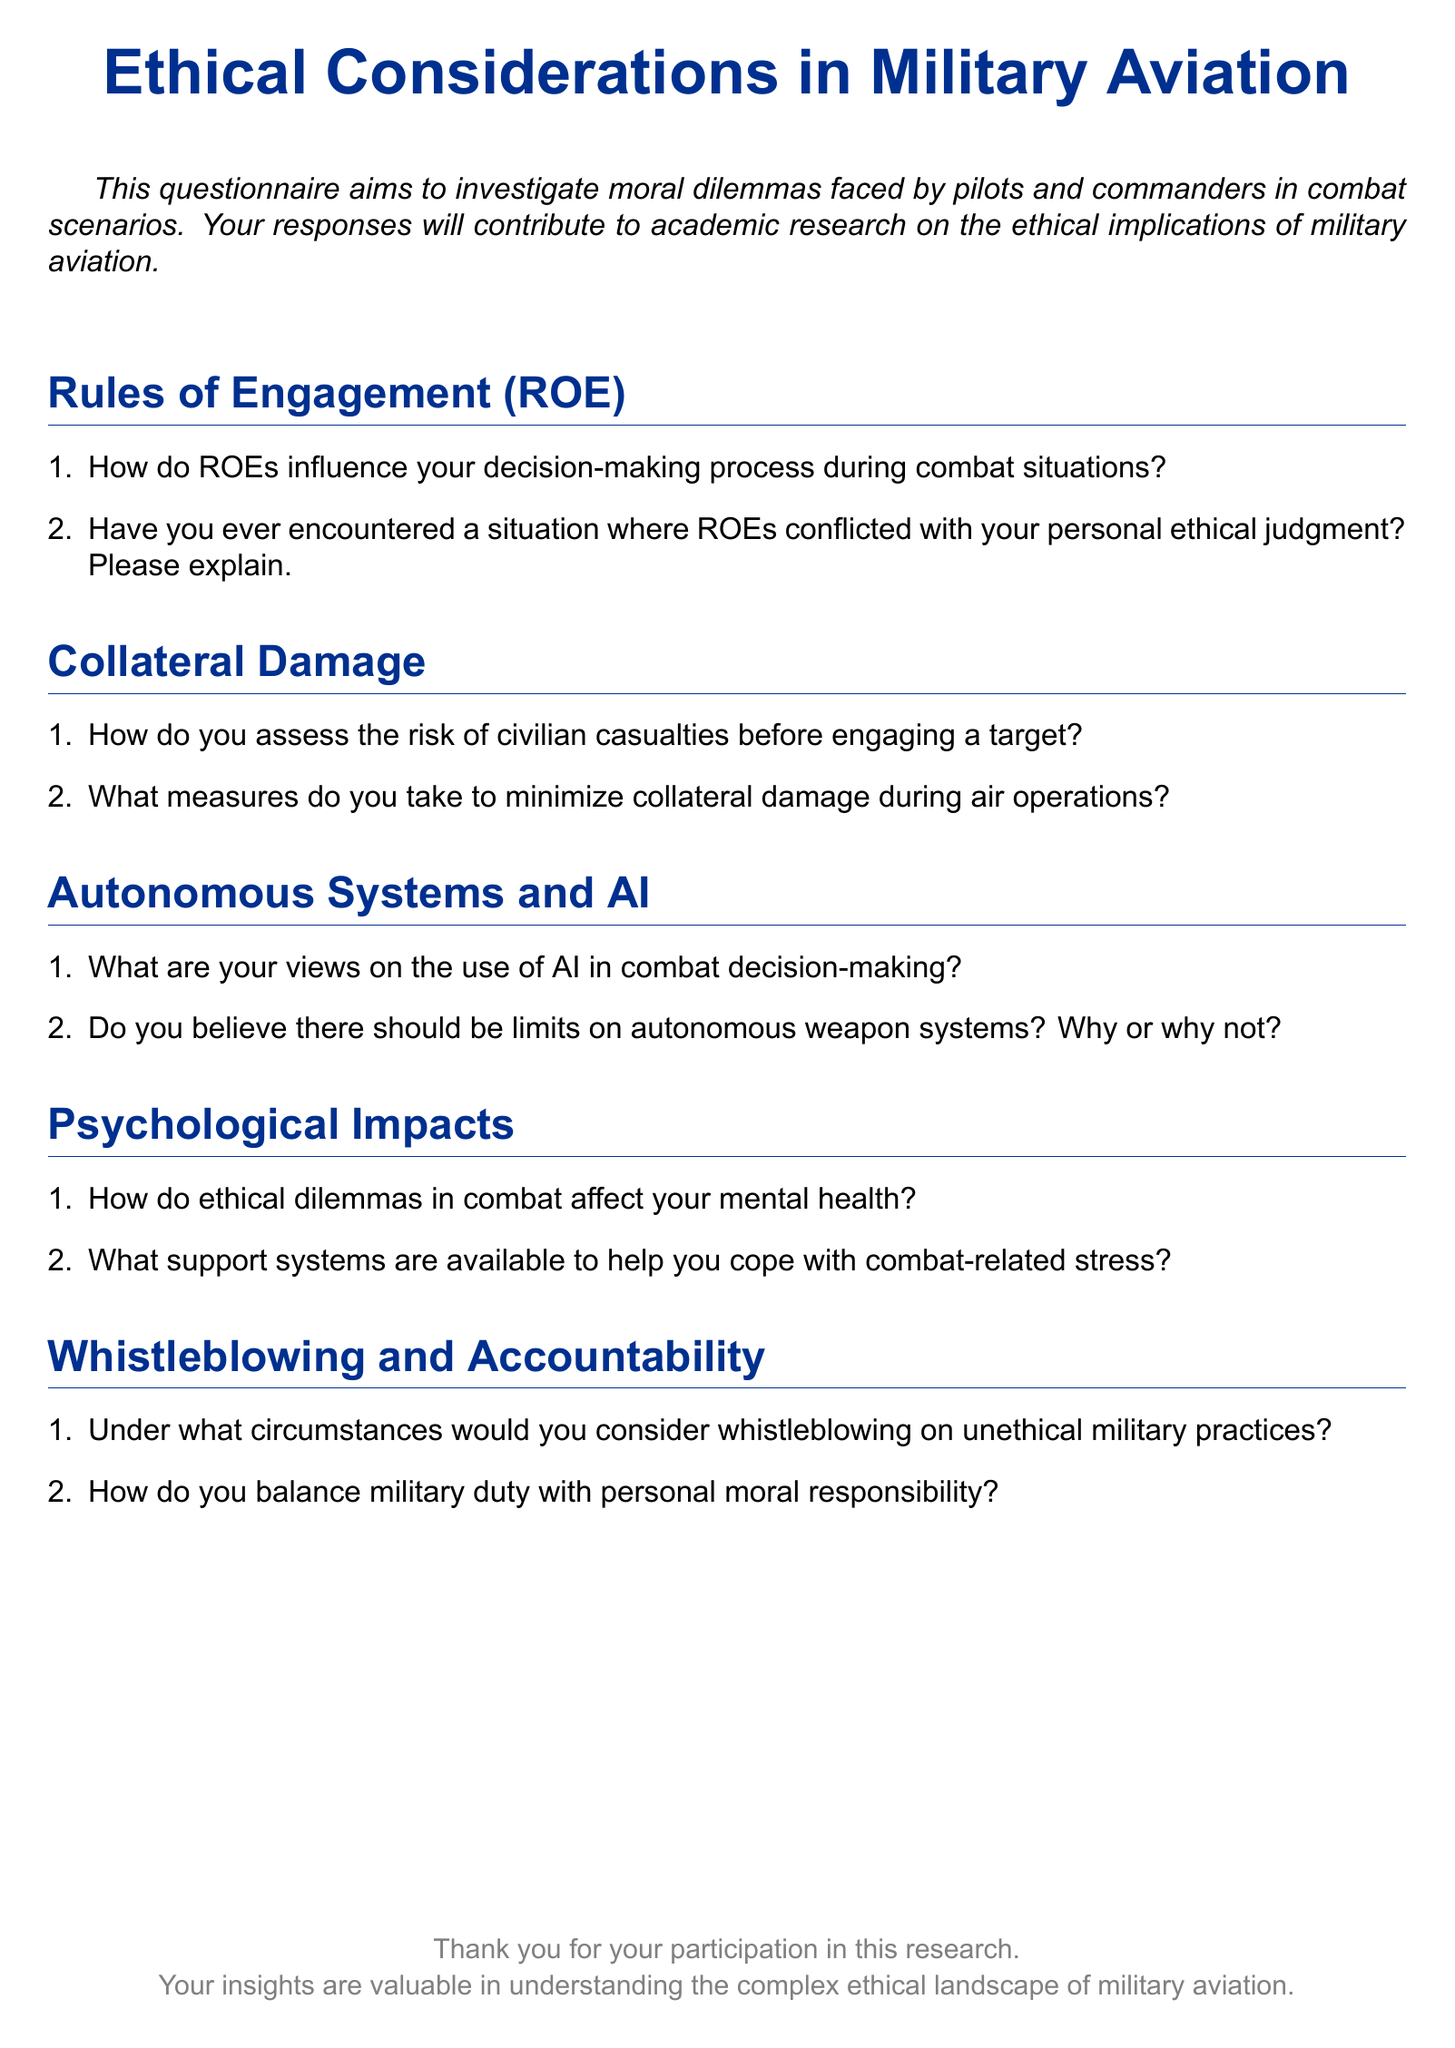What is the title of the document? The title of the document is prominently displayed at the top and is "Ethical Considerations in Military Aviation."
Answer: Ethical Considerations in Military Aviation What is the main purpose of the questionnaire? The main purpose is stated in the introduction, which explains that the questionnaire aims to investigate moral dilemmas faced by pilots and commanders.
Answer: Investigate moral dilemmas faced by pilots and commanders How many sections are there in the questionnaire? The document outlines five distinct sections focused on different ethical aspects of military aviation.
Answer: Five What color is used for the section titles? The document specifies a color associated with the section titles, which is a shade of blue identified in the document.
Answer: Airforce blue What is the concluding remark of the document? The concluding remark thanks participants for their contribution and highlights the value of their insights.
Answer: Thank you for your participation in this research Under which section would you find questions about AI in combat? The document divides its content into sections, and questions about AI can be found under a specific section name.
Answer: Autonomous Systems and AI 